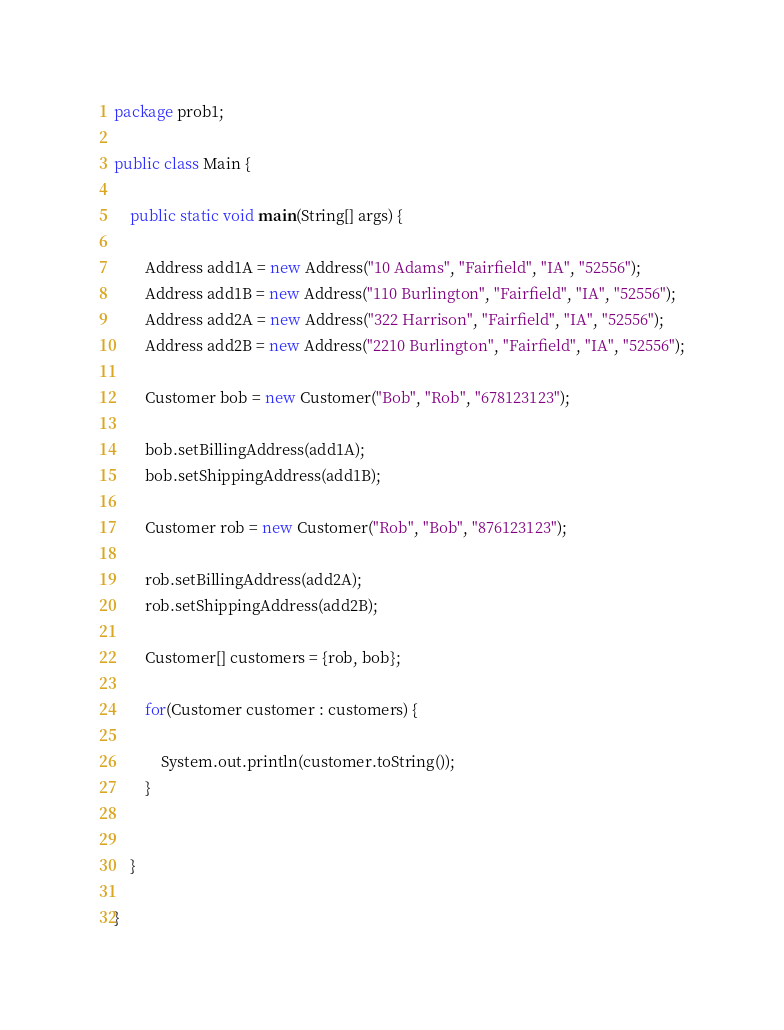Convert code to text. <code><loc_0><loc_0><loc_500><loc_500><_Java_>package prob1;

public class Main {

	public static void main(String[] args) {

		Address add1A = new Address("10 Adams", "Fairfield", "IA", "52556");
		Address add1B = new Address("110 Burlington", "Fairfield", "IA", "52556");
		Address add2A = new Address("322 Harrison", "Fairfield", "IA", "52556");
		Address add2B = new Address("2210 Burlington", "Fairfield", "IA", "52556");

		Customer bob = new Customer("Bob", "Rob", "678123123");

		bob.setBillingAddress(add1A);
		bob.setShippingAddress(add1B);

		Customer rob = new Customer("Rob", "Bob", "876123123");

		rob.setBillingAddress(add2A);
		rob.setShippingAddress(add2B);
		
		Customer[] customers = {rob, bob};
		
		for(Customer customer : customers) {
			
			System.out.println(customer.toString());
		}


	}

}
</code> 